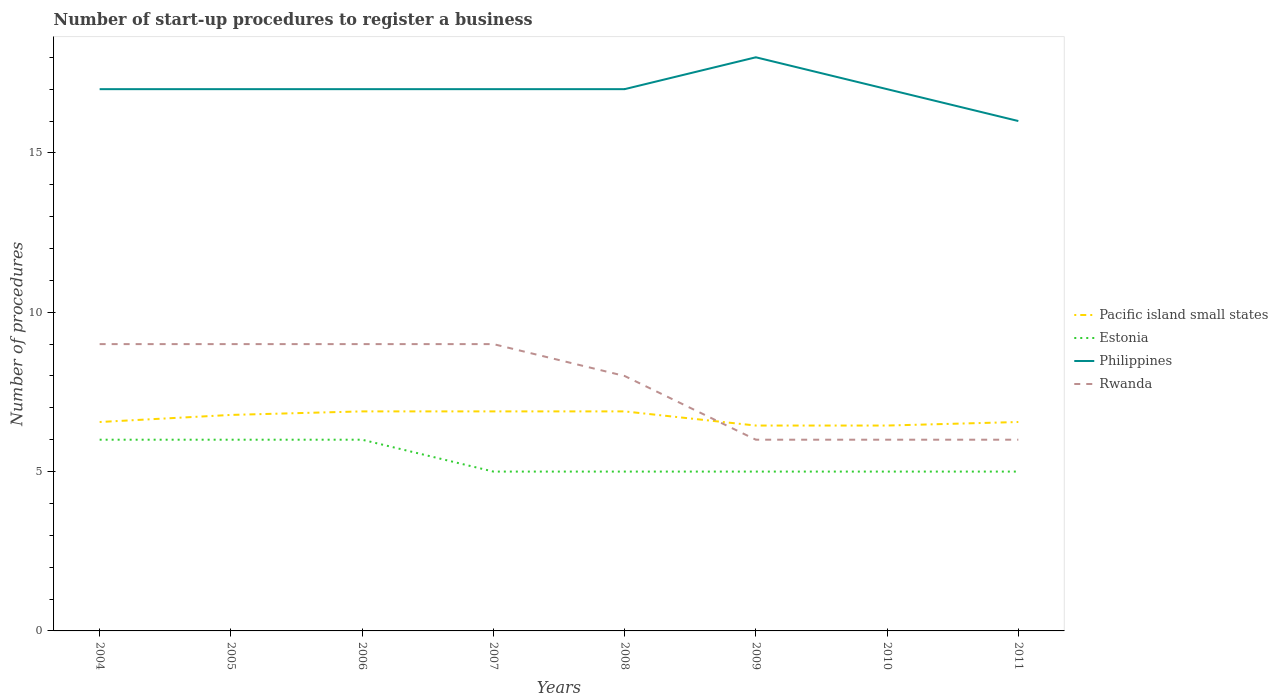Is the number of lines equal to the number of legend labels?
Provide a succinct answer. Yes. Across all years, what is the maximum number of procedures required to register a business in Pacific island small states?
Give a very brief answer. 6.44. In which year was the number of procedures required to register a business in Philippines maximum?
Give a very brief answer. 2011. What is the difference between the highest and the second highest number of procedures required to register a business in Pacific island small states?
Your response must be concise. 0.44. What is the difference between the highest and the lowest number of procedures required to register a business in Pacific island small states?
Your answer should be very brief. 4. Is the number of procedures required to register a business in Pacific island small states strictly greater than the number of procedures required to register a business in Estonia over the years?
Ensure brevity in your answer.  No. How many lines are there?
Give a very brief answer. 4. How many years are there in the graph?
Offer a terse response. 8. What is the difference between two consecutive major ticks on the Y-axis?
Ensure brevity in your answer.  5. Does the graph contain grids?
Keep it short and to the point. No. Where does the legend appear in the graph?
Your answer should be very brief. Center right. How many legend labels are there?
Give a very brief answer. 4. How are the legend labels stacked?
Offer a terse response. Vertical. What is the title of the graph?
Your answer should be very brief. Number of start-up procedures to register a business. Does "Iceland" appear as one of the legend labels in the graph?
Make the answer very short. No. What is the label or title of the Y-axis?
Give a very brief answer. Number of procedures. What is the Number of procedures of Pacific island small states in 2004?
Offer a terse response. 6.56. What is the Number of procedures in Estonia in 2004?
Ensure brevity in your answer.  6. What is the Number of procedures of Pacific island small states in 2005?
Ensure brevity in your answer.  6.78. What is the Number of procedures of Pacific island small states in 2006?
Provide a short and direct response. 6.89. What is the Number of procedures of Estonia in 2006?
Provide a short and direct response. 6. What is the Number of procedures in Pacific island small states in 2007?
Your response must be concise. 6.89. What is the Number of procedures of Philippines in 2007?
Your response must be concise. 17. What is the Number of procedures in Rwanda in 2007?
Offer a very short reply. 9. What is the Number of procedures of Pacific island small states in 2008?
Make the answer very short. 6.89. What is the Number of procedures of Rwanda in 2008?
Your answer should be very brief. 8. What is the Number of procedures of Pacific island small states in 2009?
Your answer should be very brief. 6.44. What is the Number of procedures of Estonia in 2009?
Offer a very short reply. 5. What is the Number of procedures of Rwanda in 2009?
Give a very brief answer. 6. What is the Number of procedures in Pacific island small states in 2010?
Give a very brief answer. 6.44. What is the Number of procedures of Rwanda in 2010?
Make the answer very short. 6. What is the Number of procedures in Pacific island small states in 2011?
Your answer should be very brief. 6.56. What is the Number of procedures in Philippines in 2011?
Offer a terse response. 16. Across all years, what is the maximum Number of procedures in Pacific island small states?
Provide a short and direct response. 6.89. Across all years, what is the maximum Number of procedures of Philippines?
Your response must be concise. 18. Across all years, what is the minimum Number of procedures in Pacific island small states?
Provide a short and direct response. 6.44. Across all years, what is the minimum Number of procedures of Estonia?
Give a very brief answer. 5. Across all years, what is the minimum Number of procedures in Philippines?
Give a very brief answer. 16. Across all years, what is the minimum Number of procedures in Rwanda?
Your response must be concise. 6. What is the total Number of procedures of Pacific island small states in the graph?
Provide a short and direct response. 53.44. What is the total Number of procedures in Philippines in the graph?
Your answer should be very brief. 136. What is the total Number of procedures of Rwanda in the graph?
Make the answer very short. 62. What is the difference between the Number of procedures in Pacific island small states in 2004 and that in 2005?
Provide a short and direct response. -0.22. What is the difference between the Number of procedures in Estonia in 2004 and that in 2005?
Provide a succinct answer. 0. What is the difference between the Number of procedures in Pacific island small states in 2004 and that in 2006?
Offer a very short reply. -0.33. What is the difference between the Number of procedures in Estonia in 2004 and that in 2006?
Your answer should be compact. 0. What is the difference between the Number of procedures of Philippines in 2004 and that in 2006?
Keep it short and to the point. 0. What is the difference between the Number of procedures of Rwanda in 2004 and that in 2006?
Keep it short and to the point. 0. What is the difference between the Number of procedures in Pacific island small states in 2004 and that in 2007?
Make the answer very short. -0.33. What is the difference between the Number of procedures of Estonia in 2004 and that in 2007?
Provide a short and direct response. 1. What is the difference between the Number of procedures in Philippines in 2004 and that in 2007?
Provide a succinct answer. 0. What is the difference between the Number of procedures of Estonia in 2004 and that in 2008?
Your answer should be very brief. 1. What is the difference between the Number of procedures of Philippines in 2004 and that in 2008?
Make the answer very short. 0. What is the difference between the Number of procedures in Philippines in 2004 and that in 2009?
Ensure brevity in your answer.  -1. What is the difference between the Number of procedures of Rwanda in 2004 and that in 2009?
Your answer should be very brief. 3. What is the difference between the Number of procedures in Rwanda in 2004 and that in 2010?
Your answer should be compact. 3. What is the difference between the Number of procedures in Philippines in 2004 and that in 2011?
Make the answer very short. 1. What is the difference between the Number of procedures of Pacific island small states in 2005 and that in 2006?
Give a very brief answer. -0.11. What is the difference between the Number of procedures in Estonia in 2005 and that in 2006?
Give a very brief answer. 0. What is the difference between the Number of procedures in Rwanda in 2005 and that in 2006?
Ensure brevity in your answer.  0. What is the difference between the Number of procedures in Pacific island small states in 2005 and that in 2007?
Ensure brevity in your answer.  -0.11. What is the difference between the Number of procedures of Estonia in 2005 and that in 2007?
Provide a short and direct response. 1. What is the difference between the Number of procedures of Rwanda in 2005 and that in 2007?
Your answer should be compact. 0. What is the difference between the Number of procedures in Pacific island small states in 2005 and that in 2008?
Offer a terse response. -0.11. What is the difference between the Number of procedures in Estonia in 2005 and that in 2008?
Offer a terse response. 1. What is the difference between the Number of procedures of Philippines in 2005 and that in 2008?
Provide a succinct answer. 0. What is the difference between the Number of procedures of Estonia in 2005 and that in 2009?
Ensure brevity in your answer.  1. What is the difference between the Number of procedures in Pacific island small states in 2005 and that in 2010?
Make the answer very short. 0.33. What is the difference between the Number of procedures of Estonia in 2005 and that in 2010?
Offer a terse response. 1. What is the difference between the Number of procedures of Pacific island small states in 2005 and that in 2011?
Your answer should be compact. 0.22. What is the difference between the Number of procedures in Philippines in 2005 and that in 2011?
Your response must be concise. 1. What is the difference between the Number of procedures in Rwanda in 2005 and that in 2011?
Your response must be concise. 3. What is the difference between the Number of procedures of Pacific island small states in 2006 and that in 2007?
Keep it short and to the point. 0. What is the difference between the Number of procedures of Rwanda in 2006 and that in 2007?
Your answer should be compact. 0. What is the difference between the Number of procedures of Philippines in 2006 and that in 2008?
Keep it short and to the point. 0. What is the difference between the Number of procedures of Rwanda in 2006 and that in 2008?
Offer a very short reply. 1. What is the difference between the Number of procedures in Pacific island small states in 2006 and that in 2009?
Ensure brevity in your answer.  0.44. What is the difference between the Number of procedures in Estonia in 2006 and that in 2009?
Your response must be concise. 1. What is the difference between the Number of procedures in Philippines in 2006 and that in 2009?
Offer a terse response. -1. What is the difference between the Number of procedures in Pacific island small states in 2006 and that in 2010?
Offer a very short reply. 0.44. What is the difference between the Number of procedures of Philippines in 2006 and that in 2010?
Your answer should be compact. 0. What is the difference between the Number of procedures of Rwanda in 2006 and that in 2010?
Your response must be concise. 3. What is the difference between the Number of procedures of Pacific island small states in 2006 and that in 2011?
Provide a succinct answer. 0.33. What is the difference between the Number of procedures of Philippines in 2006 and that in 2011?
Your answer should be very brief. 1. What is the difference between the Number of procedures in Rwanda in 2006 and that in 2011?
Ensure brevity in your answer.  3. What is the difference between the Number of procedures in Philippines in 2007 and that in 2008?
Your answer should be very brief. 0. What is the difference between the Number of procedures of Pacific island small states in 2007 and that in 2009?
Offer a very short reply. 0.44. What is the difference between the Number of procedures of Estonia in 2007 and that in 2009?
Ensure brevity in your answer.  0. What is the difference between the Number of procedures of Pacific island small states in 2007 and that in 2010?
Provide a succinct answer. 0.44. What is the difference between the Number of procedures in Estonia in 2007 and that in 2010?
Offer a terse response. 0. What is the difference between the Number of procedures of Philippines in 2007 and that in 2010?
Your answer should be very brief. 0. What is the difference between the Number of procedures in Pacific island small states in 2008 and that in 2009?
Make the answer very short. 0.44. What is the difference between the Number of procedures of Philippines in 2008 and that in 2009?
Offer a terse response. -1. What is the difference between the Number of procedures of Pacific island small states in 2008 and that in 2010?
Your response must be concise. 0.44. What is the difference between the Number of procedures in Rwanda in 2008 and that in 2010?
Keep it short and to the point. 2. What is the difference between the Number of procedures in Pacific island small states in 2008 and that in 2011?
Keep it short and to the point. 0.33. What is the difference between the Number of procedures of Philippines in 2008 and that in 2011?
Make the answer very short. 1. What is the difference between the Number of procedures of Pacific island small states in 2009 and that in 2011?
Keep it short and to the point. -0.11. What is the difference between the Number of procedures in Estonia in 2009 and that in 2011?
Offer a terse response. 0. What is the difference between the Number of procedures in Rwanda in 2009 and that in 2011?
Your answer should be very brief. 0. What is the difference between the Number of procedures in Pacific island small states in 2010 and that in 2011?
Ensure brevity in your answer.  -0.11. What is the difference between the Number of procedures of Estonia in 2010 and that in 2011?
Your answer should be compact. 0. What is the difference between the Number of procedures in Philippines in 2010 and that in 2011?
Your response must be concise. 1. What is the difference between the Number of procedures in Pacific island small states in 2004 and the Number of procedures in Estonia in 2005?
Offer a very short reply. 0.56. What is the difference between the Number of procedures in Pacific island small states in 2004 and the Number of procedures in Philippines in 2005?
Your answer should be very brief. -10.44. What is the difference between the Number of procedures in Pacific island small states in 2004 and the Number of procedures in Rwanda in 2005?
Provide a succinct answer. -2.44. What is the difference between the Number of procedures in Estonia in 2004 and the Number of procedures in Philippines in 2005?
Provide a short and direct response. -11. What is the difference between the Number of procedures in Pacific island small states in 2004 and the Number of procedures in Estonia in 2006?
Give a very brief answer. 0.56. What is the difference between the Number of procedures in Pacific island small states in 2004 and the Number of procedures in Philippines in 2006?
Make the answer very short. -10.44. What is the difference between the Number of procedures of Pacific island small states in 2004 and the Number of procedures of Rwanda in 2006?
Provide a short and direct response. -2.44. What is the difference between the Number of procedures in Estonia in 2004 and the Number of procedures in Philippines in 2006?
Offer a very short reply. -11. What is the difference between the Number of procedures of Estonia in 2004 and the Number of procedures of Rwanda in 2006?
Your answer should be compact. -3. What is the difference between the Number of procedures of Philippines in 2004 and the Number of procedures of Rwanda in 2006?
Give a very brief answer. 8. What is the difference between the Number of procedures of Pacific island small states in 2004 and the Number of procedures of Estonia in 2007?
Offer a terse response. 1.56. What is the difference between the Number of procedures of Pacific island small states in 2004 and the Number of procedures of Philippines in 2007?
Your answer should be very brief. -10.44. What is the difference between the Number of procedures in Pacific island small states in 2004 and the Number of procedures in Rwanda in 2007?
Your answer should be compact. -2.44. What is the difference between the Number of procedures in Estonia in 2004 and the Number of procedures in Philippines in 2007?
Your answer should be very brief. -11. What is the difference between the Number of procedures of Philippines in 2004 and the Number of procedures of Rwanda in 2007?
Provide a short and direct response. 8. What is the difference between the Number of procedures in Pacific island small states in 2004 and the Number of procedures in Estonia in 2008?
Your answer should be very brief. 1.56. What is the difference between the Number of procedures of Pacific island small states in 2004 and the Number of procedures of Philippines in 2008?
Provide a succinct answer. -10.44. What is the difference between the Number of procedures of Pacific island small states in 2004 and the Number of procedures of Rwanda in 2008?
Offer a terse response. -1.44. What is the difference between the Number of procedures in Estonia in 2004 and the Number of procedures in Philippines in 2008?
Keep it short and to the point. -11. What is the difference between the Number of procedures in Philippines in 2004 and the Number of procedures in Rwanda in 2008?
Ensure brevity in your answer.  9. What is the difference between the Number of procedures of Pacific island small states in 2004 and the Number of procedures of Estonia in 2009?
Give a very brief answer. 1.56. What is the difference between the Number of procedures in Pacific island small states in 2004 and the Number of procedures in Philippines in 2009?
Your answer should be very brief. -11.44. What is the difference between the Number of procedures of Pacific island small states in 2004 and the Number of procedures of Rwanda in 2009?
Ensure brevity in your answer.  0.56. What is the difference between the Number of procedures of Estonia in 2004 and the Number of procedures of Philippines in 2009?
Keep it short and to the point. -12. What is the difference between the Number of procedures in Philippines in 2004 and the Number of procedures in Rwanda in 2009?
Your answer should be very brief. 11. What is the difference between the Number of procedures in Pacific island small states in 2004 and the Number of procedures in Estonia in 2010?
Offer a very short reply. 1.56. What is the difference between the Number of procedures in Pacific island small states in 2004 and the Number of procedures in Philippines in 2010?
Your answer should be very brief. -10.44. What is the difference between the Number of procedures of Pacific island small states in 2004 and the Number of procedures of Rwanda in 2010?
Offer a terse response. 0.56. What is the difference between the Number of procedures of Pacific island small states in 2004 and the Number of procedures of Estonia in 2011?
Provide a short and direct response. 1.56. What is the difference between the Number of procedures of Pacific island small states in 2004 and the Number of procedures of Philippines in 2011?
Give a very brief answer. -9.44. What is the difference between the Number of procedures in Pacific island small states in 2004 and the Number of procedures in Rwanda in 2011?
Ensure brevity in your answer.  0.56. What is the difference between the Number of procedures in Pacific island small states in 2005 and the Number of procedures in Estonia in 2006?
Your response must be concise. 0.78. What is the difference between the Number of procedures of Pacific island small states in 2005 and the Number of procedures of Philippines in 2006?
Your answer should be very brief. -10.22. What is the difference between the Number of procedures of Pacific island small states in 2005 and the Number of procedures of Rwanda in 2006?
Your answer should be compact. -2.22. What is the difference between the Number of procedures in Estonia in 2005 and the Number of procedures in Philippines in 2006?
Give a very brief answer. -11. What is the difference between the Number of procedures in Estonia in 2005 and the Number of procedures in Rwanda in 2006?
Provide a succinct answer. -3. What is the difference between the Number of procedures of Pacific island small states in 2005 and the Number of procedures of Estonia in 2007?
Make the answer very short. 1.78. What is the difference between the Number of procedures of Pacific island small states in 2005 and the Number of procedures of Philippines in 2007?
Provide a succinct answer. -10.22. What is the difference between the Number of procedures in Pacific island small states in 2005 and the Number of procedures in Rwanda in 2007?
Offer a terse response. -2.22. What is the difference between the Number of procedures of Estonia in 2005 and the Number of procedures of Philippines in 2007?
Provide a short and direct response. -11. What is the difference between the Number of procedures of Pacific island small states in 2005 and the Number of procedures of Estonia in 2008?
Give a very brief answer. 1.78. What is the difference between the Number of procedures in Pacific island small states in 2005 and the Number of procedures in Philippines in 2008?
Provide a succinct answer. -10.22. What is the difference between the Number of procedures of Pacific island small states in 2005 and the Number of procedures of Rwanda in 2008?
Keep it short and to the point. -1.22. What is the difference between the Number of procedures of Estonia in 2005 and the Number of procedures of Rwanda in 2008?
Your response must be concise. -2. What is the difference between the Number of procedures in Pacific island small states in 2005 and the Number of procedures in Estonia in 2009?
Provide a succinct answer. 1.78. What is the difference between the Number of procedures of Pacific island small states in 2005 and the Number of procedures of Philippines in 2009?
Provide a succinct answer. -11.22. What is the difference between the Number of procedures of Pacific island small states in 2005 and the Number of procedures of Rwanda in 2009?
Keep it short and to the point. 0.78. What is the difference between the Number of procedures in Estonia in 2005 and the Number of procedures in Philippines in 2009?
Ensure brevity in your answer.  -12. What is the difference between the Number of procedures of Pacific island small states in 2005 and the Number of procedures of Estonia in 2010?
Give a very brief answer. 1.78. What is the difference between the Number of procedures in Pacific island small states in 2005 and the Number of procedures in Philippines in 2010?
Your answer should be very brief. -10.22. What is the difference between the Number of procedures in Pacific island small states in 2005 and the Number of procedures in Rwanda in 2010?
Your answer should be very brief. 0.78. What is the difference between the Number of procedures of Estonia in 2005 and the Number of procedures of Rwanda in 2010?
Your answer should be compact. 0. What is the difference between the Number of procedures in Pacific island small states in 2005 and the Number of procedures in Estonia in 2011?
Your answer should be very brief. 1.78. What is the difference between the Number of procedures in Pacific island small states in 2005 and the Number of procedures in Philippines in 2011?
Keep it short and to the point. -9.22. What is the difference between the Number of procedures of Pacific island small states in 2006 and the Number of procedures of Estonia in 2007?
Keep it short and to the point. 1.89. What is the difference between the Number of procedures of Pacific island small states in 2006 and the Number of procedures of Philippines in 2007?
Make the answer very short. -10.11. What is the difference between the Number of procedures of Pacific island small states in 2006 and the Number of procedures of Rwanda in 2007?
Give a very brief answer. -2.11. What is the difference between the Number of procedures of Estonia in 2006 and the Number of procedures of Philippines in 2007?
Your response must be concise. -11. What is the difference between the Number of procedures in Estonia in 2006 and the Number of procedures in Rwanda in 2007?
Give a very brief answer. -3. What is the difference between the Number of procedures in Pacific island small states in 2006 and the Number of procedures in Estonia in 2008?
Give a very brief answer. 1.89. What is the difference between the Number of procedures of Pacific island small states in 2006 and the Number of procedures of Philippines in 2008?
Provide a short and direct response. -10.11. What is the difference between the Number of procedures in Pacific island small states in 2006 and the Number of procedures in Rwanda in 2008?
Your answer should be very brief. -1.11. What is the difference between the Number of procedures of Philippines in 2006 and the Number of procedures of Rwanda in 2008?
Ensure brevity in your answer.  9. What is the difference between the Number of procedures in Pacific island small states in 2006 and the Number of procedures in Estonia in 2009?
Ensure brevity in your answer.  1.89. What is the difference between the Number of procedures of Pacific island small states in 2006 and the Number of procedures of Philippines in 2009?
Ensure brevity in your answer.  -11.11. What is the difference between the Number of procedures of Pacific island small states in 2006 and the Number of procedures of Rwanda in 2009?
Your answer should be very brief. 0.89. What is the difference between the Number of procedures in Estonia in 2006 and the Number of procedures in Philippines in 2009?
Offer a terse response. -12. What is the difference between the Number of procedures in Philippines in 2006 and the Number of procedures in Rwanda in 2009?
Your answer should be very brief. 11. What is the difference between the Number of procedures of Pacific island small states in 2006 and the Number of procedures of Estonia in 2010?
Offer a terse response. 1.89. What is the difference between the Number of procedures of Pacific island small states in 2006 and the Number of procedures of Philippines in 2010?
Keep it short and to the point. -10.11. What is the difference between the Number of procedures in Philippines in 2006 and the Number of procedures in Rwanda in 2010?
Keep it short and to the point. 11. What is the difference between the Number of procedures of Pacific island small states in 2006 and the Number of procedures of Estonia in 2011?
Offer a very short reply. 1.89. What is the difference between the Number of procedures of Pacific island small states in 2006 and the Number of procedures of Philippines in 2011?
Provide a succinct answer. -9.11. What is the difference between the Number of procedures in Pacific island small states in 2007 and the Number of procedures in Estonia in 2008?
Ensure brevity in your answer.  1.89. What is the difference between the Number of procedures of Pacific island small states in 2007 and the Number of procedures of Philippines in 2008?
Ensure brevity in your answer.  -10.11. What is the difference between the Number of procedures of Pacific island small states in 2007 and the Number of procedures of Rwanda in 2008?
Make the answer very short. -1.11. What is the difference between the Number of procedures in Estonia in 2007 and the Number of procedures in Philippines in 2008?
Your answer should be compact. -12. What is the difference between the Number of procedures of Pacific island small states in 2007 and the Number of procedures of Estonia in 2009?
Provide a short and direct response. 1.89. What is the difference between the Number of procedures in Pacific island small states in 2007 and the Number of procedures in Philippines in 2009?
Your answer should be compact. -11.11. What is the difference between the Number of procedures of Estonia in 2007 and the Number of procedures of Philippines in 2009?
Offer a terse response. -13. What is the difference between the Number of procedures in Philippines in 2007 and the Number of procedures in Rwanda in 2009?
Your answer should be very brief. 11. What is the difference between the Number of procedures of Pacific island small states in 2007 and the Number of procedures of Estonia in 2010?
Offer a terse response. 1.89. What is the difference between the Number of procedures in Pacific island small states in 2007 and the Number of procedures in Philippines in 2010?
Your answer should be compact. -10.11. What is the difference between the Number of procedures of Estonia in 2007 and the Number of procedures of Philippines in 2010?
Make the answer very short. -12. What is the difference between the Number of procedures in Estonia in 2007 and the Number of procedures in Rwanda in 2010?
Ensure brevity in your answer.  -1. What is the difference between the Number of procedures of Pacific island small states in 2007 and the Number of procedures of Estonia in 2011?
Offer a terse response. 1.89. What is the difference between the Number of procedures of Pacific island small states in 2007 and the Number of procedures of Philippines in 2011?
Provide a succinct answer. -9.11. What is the difference between the Number of procedures in Pacific island small states in 2007 and the Number of procedures in Rwanda in 2011?
Your response must be concise. 0.89. What is the difference between the Number of procedures in Estonia in 2007 and the Number of procedures in Rwanda in 2011?
Keep it short and to the point. -1. What is the difference between the Number of procedures of Pacific island small states in 2008 and the Number of procedures of Estonia in 2009?
Your answer should be very brief. 1.89. What is the difference between the Number of procedures in Pacific island small states in 2008 and the Number of procedures in Philippines in 2009?
Ensure brevity in your answer.  -11.11. What is the difference between the Number of procedures of Pacific island small states in 2008 and the Number of procedures of Rwanda in 2009?
Offer a very short reply. 0.89. What is the difference between the Number of procedures of Estonia in 2008 and the Number of procedures of Philippines in 2009?
Make the answer very short. -13. What is the difference between the Number of procedures of Estonia in 2008 and the Number of procedures of Rwanda in 2009?
Give a very brief answer. -1. What is the difference between the Number of procedures of Philippines in 2008 and the Number of procedures of Rwanda in 2009?
Ensure brevity in your answer.  11. What is the difference between the Number of procedures of Pacific island small states in 2008 and the Number of procedures of Estonia in 2010?
Offer a terse response. 1.89. What is the difference between the Number of procedures in Pacific island small states in 2008 and the Number of procedures in Philippines in 2010?
Ensure brevity in your answer.  -10.11. What is the difference between the Number of procedures in Pacific island small states in 2008 and the Number of procedures in Estonia in 2011?
Provide a short and direct response. 1.89. What is the difference between the Number of procedures in Pacific island small states in 2008 and the Number of procedures in Philippines in 2011?
Provide a short and direct response. -9.11. What is the difference between the Number of procedures of Estonia in 2008 and the Number of procedures of Philippines in 2011?
Provide a succinct answer. -11. What is the difference between the Number of procedures of Estonia in 2008 and the Number of procedures of Rwanda in 2011?
Offer a terse response. -1. What is the difference between the Number of procedures of Pacific island small states in 2009 and the Number of procedures of Estonia in 2010?
Offer a very short reply. 1.44. What is the difference between the Number of procedures of Pacific island small states in 2009 and the Number of procedures of Philippines in 2010?
Give a very brief answer. -10.56. What is the difference between the Number of procedures in Pacific island small states in 2009 and the Number of procedures in Rwanda in 2010?
Your response must be concise. 0.44. What is the difference between the Number of procedures in Estonia in 2009 and the Number of procedures in Philippines in 2010?
Offer a very short reply. -12. What is the difference between the Number of procedures of Estonia in 2009 and the Number of procedures of Rwanda in 2010?
Give a very brief answer. -1. What is the difference between the Number of procedures of Pacific island small states in 2009 and the Number of procedures of Estonia in 2011?
Your answer should be very brief. 1.44. What is the difference between the Number of procedures in Pacific island small states in 2009 and the Number of procedures in Philippines in 2011?
Your response must be concise. -9.56. What is the difference between the Number of procedures of Pacific island small states in 2009 and the Number of procedures of Rwanda in 2011?
Provide a succinct answer. 0.44. What is the difference between the Number of procedures of Philippines in 2009 and the Number of procedures of Rwanda in 2011?
Your answer should be very brief. 12. What is the difference between the Number of procedures in Pacific island small states in 2010 and the Number of procedures in Estonia in 2011?
Your response must be concise. 1.44. What is the difference between the Number of procedures of Pacific island small states in 2010 and the Number of procedures of Philippines in 2011?
Give a very brief answer. -9.56. What is the difference between the Number of procedures in Pacific island small states in 2010 and the Number of procedures in Rwanda in 2011?
Your response must be concise. 0.44. What is the difference between the Number of procedures of Estonia in 2010 and the Number of procedures of Philippines in 2011?
Ensure brevity in your answer.  -11. What is the difference between the Number of procedures of Philippines in 2010 and the Number of procedures of Rwanda in 2011?
Offer a very short reply. 11. What is the average Number of procedures in Pacific island small states per year?
Provide a short and direct response. 6.68. What is the average Number of procedures of Estonia per year?
Ensure brevity in your answer.  5.38. What is the average Number of procedures of Rwanda per year?
Keep it short and to the point. 7.75. In the year 2004, what is the difference between the Number of procedures in Pacific island small states and Number of procedures in Estonia?
Your answer should be compact. 0.56. In the year 2004, what is the difference between the Number of procedures in Pacific island small states and Number of procedures in Philippines?
Make the answer very short. -10.44. In the year 2004, what is the difference between the Number of procedures in Pacific island small states and Number of procedures in Rwanda?
Give a very brief answer. -2.44. In the year 2004, what is the difference between the Number of procedures in Estonia and Number of procedures in Philippines?
Make the answer very short. -11. In the year 2004, what is the difference between the Number of procedures in Estonia and Number of procedures in Rwanda?
Your answer should be compact. -3. In the year 2005, what is the difference between the Number of procedures in Pacific island small states and Number of procedures in Philippines?
Make the answer very short. -10.22. In the year 2005, what is the difference between the Number of procedures in Pacific island small states and Number of procedures in Rwanda?
Ensure brevity in your answer.  -2.22. In the year 2005, what is the difference between the Number of procedures of Estonia and Number of procedures of Rwanda?
Your answer should be very brief. -3. In the year 2005, what is the difference between the Number of procedures in Philippines and Number of procedures in Rwanda?
Provide a succinct answer. 8. In the year 2006, what is the difference between the Number of procedures of Pacific island small states and Number of procedures of Philippines?
Offer a very short reply. -10.11. In the year 2006, what is the difference between the Number of procedures of Pacific island small states and Number of procedures of Rwanda?
Keep it short and to the point. -2.11. In the year 2006, what is the difference between the Number of procedures in Estonia and Number of procedures in Rwanda?
Make the answer very short. -3. In the year 2007, what is the difference between the Number of procedures in Pacific island small states and Number of procedures in Estonia?
Provide a short and direct response. 1.89. In the year 2007, what is the difference between the Number of procedures of Pacific island small states and Number of procedures of Philippines?
Make the answer very short. -10.11. In the year 2007, what is the difference between the Number of procedures in Pacific island small states and Number of procedures in Rwanda?
Make the answer very short. -2.11. In the year 2007, what is the difference between the Number of procedures of Estonia and Number of procedures of Philippines?
Your response must be concise. -12. In the year 2008, what is the difference between the Number of procedures in Pacific island small states and Number of procedures in Estonia?
Keep it short and to the point. 1.89. In the year 2008, what is the difference between the Number of procedures in Pacific island small states and Number of procedures in Philippines?
Give a very brief answer. -10.11. In the year 2008, what is the difference between the Number of procedures in Pacific island small states and Number of procedures in Rwanda?
Give a very brief answer. -1.11. In the year 2008, what is the difference between the Number of procedures of Estonia and Number of procedures of Philippines?
Your answer should be compact. -12. In the year 2008, what is the difference between the Number of procedures of Philippines and Number of procedures of Rwanda?
Offer a very short reply. 9. In the year 2009, what is the difference between the Number of procedures of Pacific island small states and Number of procedures of Estonia?
Provide a succinct answer. 1.44. In the year 2009, what is the difference between the Number of procedures in Pacific island small states and Number of procedures in Philippines?
Keep it short and to the point. -11.56. In the year 2009, what is the difference between the Number of procedures in Pacific island small states and Number of procedures in Rwanda?
Offer a very short reply. 0.44. In the year 2009, what is the difference between the Number of procedures of Estonia and Number of procedures of Rwanda?
Provide a short and direct response. -1. In the year 2010, what is the difference between the Number of procedures in Pacific island small states and Number of procedures in Estonia?
Your response must be concise. 1.44. In the year 2010, what is the difference between the Number of procedures of Pacific island small states and Number of procedures of Philippines?
Keep it short and to the point. -10.56. In the year 2010, what is the difference between the Number of procedures in Pacific island small states and Number of procedures in Rwanda?
Make the answer very short. 0.44. In the year 2010, what is the difference between the Number of procedures of Estonia and Number of procedures of Philippines?
Provide a short and direct response. -12. In the year 2010, what is the difference between the Number of procedures of Estonia and Number of procedures of Rwanda?
Your response must be concise. -1. In the year 2010, what is the difference between the Number of procedures of Philippines and Number of procedures of Rwanda?
Provide a short and direct response. 11. In the year 2011, what is the difference between the Number of procedures of Pacific island small states and Number of procedures of Estonia?
Give a very brief answer. 1.56. In the year 2011, what is the difference between the Number of procedures in Pacific island small states and Number of procedures in Philippines?
Ensure brevity in your answer.  -9.44. In the year 2011, what is the difference between the Number of procedures of Pacific island small states and Number of procedures of Rwanda?
Make the answer very short. 0.56. In the year 2011, what is the difference between the Number of procedures in Estonia and Number of procedures in Philippines?
Offer a terse response. -11. In the year 2011, what is the difference between the Number of procedures of Philippines and Number of procedures of Rwanda?
Provide a succinct answer. 10. What is the ratio of the Number of procedures of Pacific island small states in 2004 to that in 2005?
Provide a succinct answer. 0.97. What is the ratio of the Number of procedures of Philippines in 2004 to that in 2005?
Your answer should be compact. 1. What is the ratio of the Number of procedures in Pacific island small states in 2004 to that in 2006?
Keep it short and to the point. 0.95. What is the ratio of the Number of procedures in Rwanda in 2004 to that in 2006?
Offer a terse response. 1. What is the ratio of the Number of procedures in Pacific island small states in 2004 to that in 2007?
Provide a short and direct response. 0.95. What is the ratio of the Number of procedures of Estonia in 2004 to that in 2007?
Your response must be concise. 1.2. What is the ratio of the Number of procedures of Rwanda in 2004 to that in 2007?
Offer a terse response. 1. What is the ratio of the Number of procedures in Pacific island small states in 2004 to that in 2008?
Provide a succinct answer. 0.95. What is the ratio of the Number of procedures of Estonia in 2004 to that in 2008?
Your answer should be compact. 1.2. What is the ratio of the Number of procedures in Philippines in 2004 to that in 2008?
Ensure brevity in your answer.  1. What is the ratio of the Number of procedures of Pacific island small states in 2004 to that in 2009?
Your answer should be very brief. 1.02. What is the ratio of the Number of procedures in Pacific island small states in 2004 to that in 2010?
Offer a very short reply. 1.02. What is the ratio of the Number of procedures of Estonia in 2004 to that in 2011?
Give a very brief answer. 1.2. What is the ratio of the Number of procedures in Philippines in 2004 to that in 2011?
Provide a short and direct response. 1.06. What is the ratio of the Number of procedures in Rwanda in 2004 to that in 2011?
Give a very brief answer. 1.5. What is the ratio of the Number of procedures of Pacific island small states in 2005 to that in 2006?
Keep it short and to the point. 0.98. What is the ratio of the Number of procedures in Estonia in 2005 to that in 2006?
Offer a very short reply. 1. What is the ratio of the Number of procedures of Philippines in 2005 to that in 2006?
Make the answer very short. 1. What is the ratio of the Number of procedures in Pacific island small states in 2005 to that in 2007?
Give a very brief answer. 0.98. What is the ratio of the Number of procedures in Rwanda in 2005 to that in 2007?
Make the answer very short. 1. What is the ratio of the Number of procedures in Pacific island small states in 2005 to that in 2008?
Ensure brevity in your answer.  0.98. What is the ratio of the Number of procedures of Estonia in 2005 to that in 2008?
Make the answer very short. 1.2. What is the ratio of the Number of procedures in Philippines in 2005 to that in 2008?
Your response must be concise. 1. What is the ratio of the Number of procedures in Rwanda in 2005 to that in 2008?
Your response must be concise. 1.12. What is the ratio of the Number of procedures in Pacific island small states in 2005 to that in 2009?
Keep it short and to the point. 1.05. What is the ratio of the Number of procedures of Estonia in 2005 to that in 2009?
Keep it short and to the point. 1.2. What is the ratio of the Number of procedures in Philippines in 2005 to that in 2009?
Ensure brevity in your answer.  0.94. What is the ratio of the Number of procedures in Rwanda in 2005 to that in 2009?
Offer a very short reply. 1.5. What is the ratio of the Number of procedures of Pacific island small states in 2005 to that in 2010?
Provide a short and direct response. 1.05. What is the ratio of the Number of procedures of Rwanda in 2005 to that in 2010?
Make the answer very short. 1.5. What is the ratio of the Number of procedures of Pacific island small states in 2005 to that in 2011?
Ensure brevity in your answer.  1.03. What is the ratio of the Number of procedures in Philippines in 2005 to that in 2011?
Your response must be concise. 1.06. What is the ratio of the Number of procedures of Rwanda in 2005 to that in 2011?
Offer a very short reply. 1.5. What is the ratio of the Number of procedures of Pacific island small states in 2006 to that in 2007?
Your response must be concise. 1. What is the ratio of the Number of procedures of Philippines in 2006 to that in 2007?
Your answer should be very brief. 1. What is the ratio of the Number of procedures in Pacific island small states in 2006 to that in 2008?
Offer a terse response. 1. What is the ratio of the Number of procedures in Philippines in 2006 to that in 2008?
Give a very brief answer. 1. What is the ratio of the Number of procedures of Rwanda in 2006 to that in 2008?
Your response must be concise. 1.12. What is the ratio of the Number of procedures of Pacific island small states in 2006 to that in 2009?
Provide a succinct answer. 1.07. What is the ratio of the Number of procedures of Estonia in 2006 to that in 2009?
Ensure brevity in your answer.  1.2. What is the ratio of the Number of procedures in Rwanda in 2006 to that in 2009?
Your response must be concise. 1.5. What is the ratio of the Number of procedures in Pacific island small states in 2006 to that in 2010?
Give a very brief answer. 1.07. What is the ratio of the Number of procedures in Estonia in 2006 to that in 2010?
Your answer should be very brief. 1.2. What is the ratio of the Number of procedures in Philippines in 2006 to that in 2010?
Make the answer very short. 1. What is the ratio of the Number of procedures of Rwanda in 2006 to that in 2010?
Offer a very short reply. 1.5. What is the ratio of the Number of procedures in Pacific island small states in 2006 to that in 2011?
Give a very brief answer. 1.05. What is the ratio of the Number of procedures of Estonia in 2006 to that in 2011?
Give a very brief answer. 1.2. What is the ratio of the Number of procedures of Philippines in 2006 to that in 2011?
Make the answer very short. 1.06. What is the ratio of the Number of procedures in Rwanda in 2006 to that in 2011?
Your response must be concise. 1.5. What is the ratio of the Number of procedures of Pacific island small states in 2007 to that in 2008?
Make the answer very short. 1. What is the ratio of the Number of procedures of Philippines in 2007 to that in 2008?
Your response must be concise. 1. What is the ratio of the Number of procedures in Pacific island small states in 2007 to that in 2009?
Your response must be concise. 1.07. What is the ratio of the Number of procedures of Estonia in 2007 to that in 2009?
Ensure brevity in your answer.  1. What is the ratio of the Number of procedures of Rwanda in 2007 to that in 2009?
Provide a succinct answer. 1.5. What is the ratio of the Number of procedures in Pacific island small states in 2007 to that in 2010?
Give a very brief answer. 1.07. What is the ratio of the Number of procedures of Philippines in 2007 to that in 2010?
Provide a short and direct response. 1. What is the ratio of the Number of procedures of Rwanda in 2007 to that in 2010?
Ensure brevity in your answer.  1.5. What is the ratio of the Number of procedures in Pacific island small states in 2007 to that in 2011?
Your response must be concise. 1.05. What is the ratio of the Number of procedures in Estonia in 2007 to that in 2011?
Your answer should be very brief. 1. What is the ratio of the Number of procedures of Rwanda in 2007 to that in 2011?
Make the answer very short. 1.5. What is the ratio of the Number of procedures of Pacific island small states in 2008 to that in 2009?
Provide a short and direct response. 1.07. What is the ratio of the Number of procedures in Estonia in 2008 to that in 2009?
Provide a succinct answer. 1. What is the ratio of the Number of procedures in Pacific island small states in 2008 to that in 2010?
Provide a succinct answer. 1.07. What is the ratio of the Number of procedures of Rwanda in 2008 to that in 2010?
Make the answer very short. 1.33. What is the ratio of the Number of procedures in Pacific island small states in 2008 to that in 2011?
Give a very brief answer. 1.05. What is the ratio of the Number of procedures in Estonia in 2008 to that in 2011?
Your answer should be very brief. 1. What is the ratio of the Number of procedures in Philippines in 2008 to that in 2011?
Provide a succinct answer. 1.06. What is the ratio of the Number of procedures of Rwanda in 2008 to that in 2011?
Keep it short and to the point. 1.33. What is the ratio of the Number of procedures in Estonia in 2009 to that in 2010?
Your answer should be compact. 1. What is the ratio of the Number of procedures in Philippines in 2009 to that in 2010?
Provide a short and direct response. 1.06. What is the ratio of the Number of procedures in Rwanda in 2009 to that in 2010?
Keep it short and to the point. 1. What is the ratio of the Number of procedures in Pacific island small states in 2009 to that in 2011?
Keep it short and to the point. 0.98. What is the ratio of the Number of procedures in Pacific island small states in 2010 to that in 2011?
Ensure brevity in your answer.  0.98. What is the ratio of the Number of procedures in Estonia in 2010 to that in 2011?
Your answer should be compact. 1. What is the difference between the highest and the second highest Number of procedures in Pacific island small states?
Your answer should be very brief. 0. What is the difference between the highest and the second highest Number of procedures of Philippines?
Ensure brevity in your answer.  1. What is the difference between the highest and the lowest Number of procedures in Pacific island small states?
Give a very brief answer. 0.44. What is the difference between the highest and the lowest Number of procedures of Rwanda?
Ensure brevity in your answer.  3. 